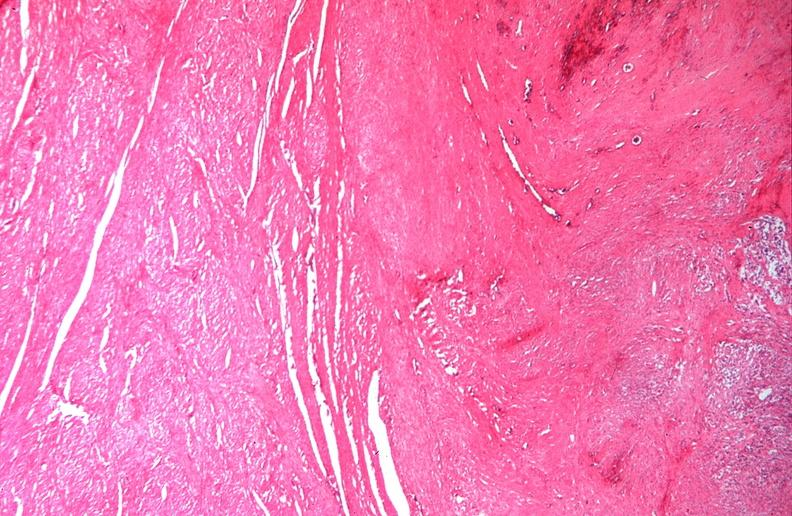where is this from?
Answer the question using a single word or phrase. Female reproductive system 